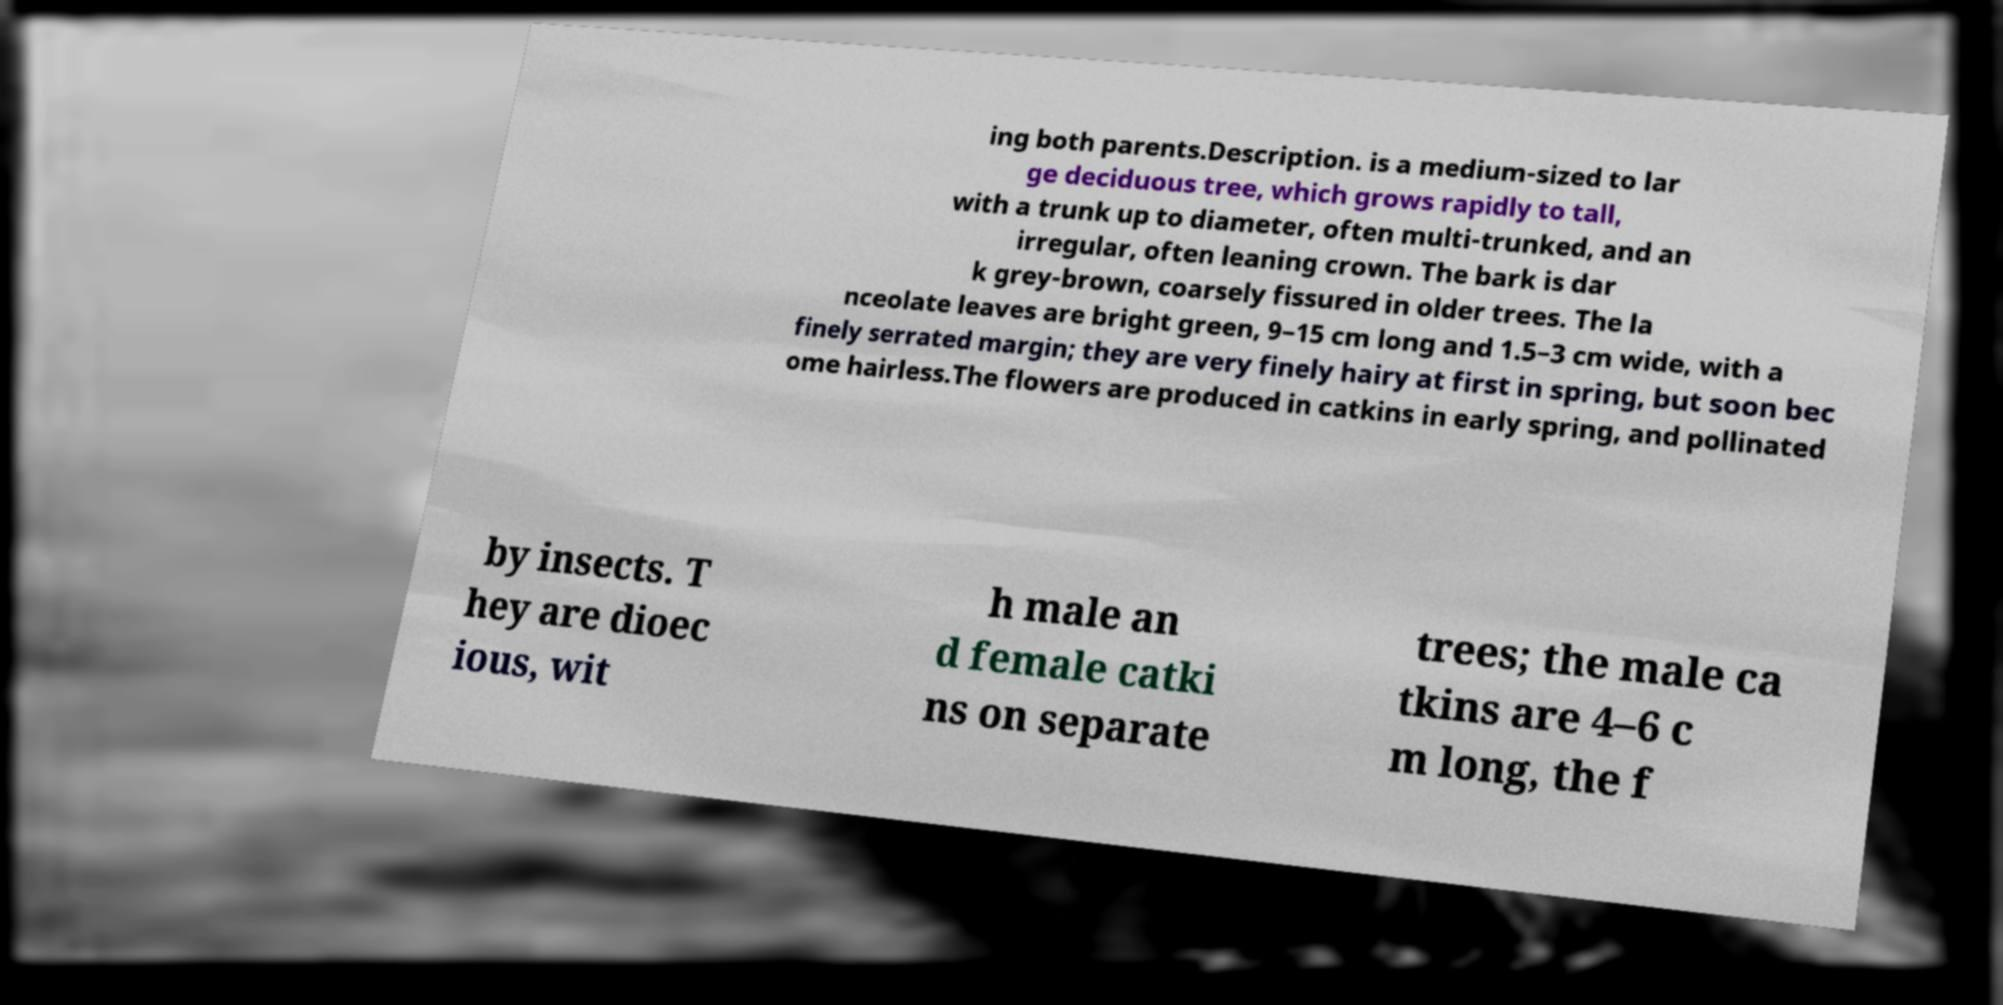There's text embedded in this image that I need extracted. Can you transcribe it verbatim? ing both parents.Description. is a medium-sized to lar ge deciduous tree, which grows rapidly to tall, with a trunk up to diameter, often multi-trunked, and an irregular, often leaning crown. The bark is dar k grey-brown, coarsely fissured in older trees. The la nceolate leaves are bright green, 9–15 cm long and 1.5–3 cm wide, with a finely serrated margin; they are very finely hairy at first in spring, but soon bec ome hairless.The flowers are produced in catkins in early spring, and pollinated by insects. T hey are dioec ious, wit h male an d female catki ns on separate trees; the male ca tkins are 4–6 c m long, the f 